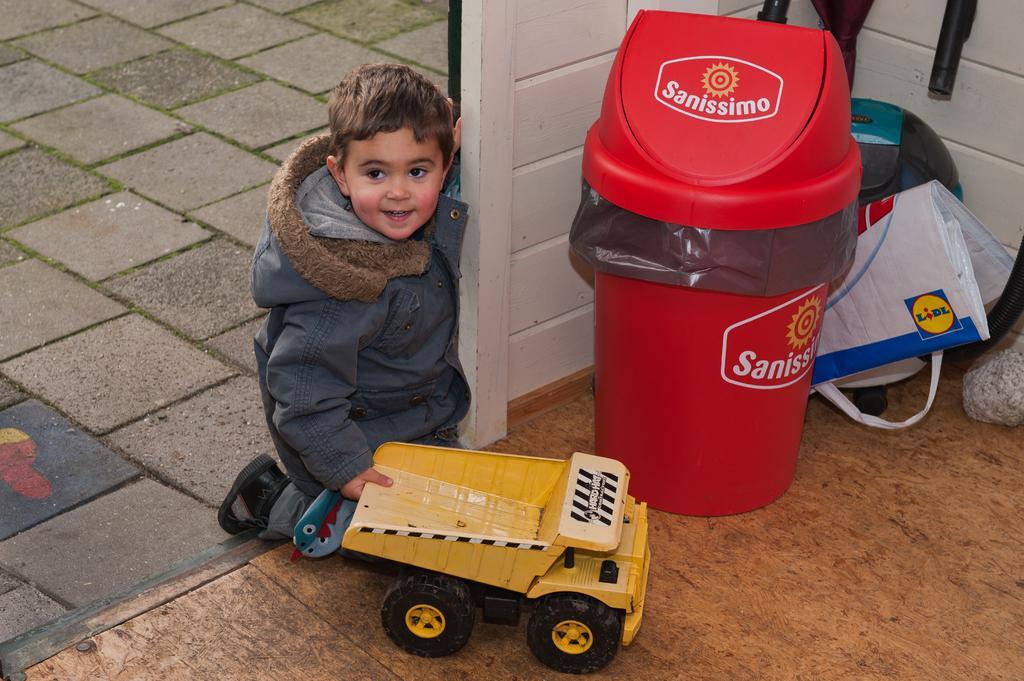Could you give a brief overview of what you see in this image? In this image we can see a child sitting on his knees holding a toy truck. We can also see some marbles and the floor. On the right side we can see a dustbin, cover and some pipes. 